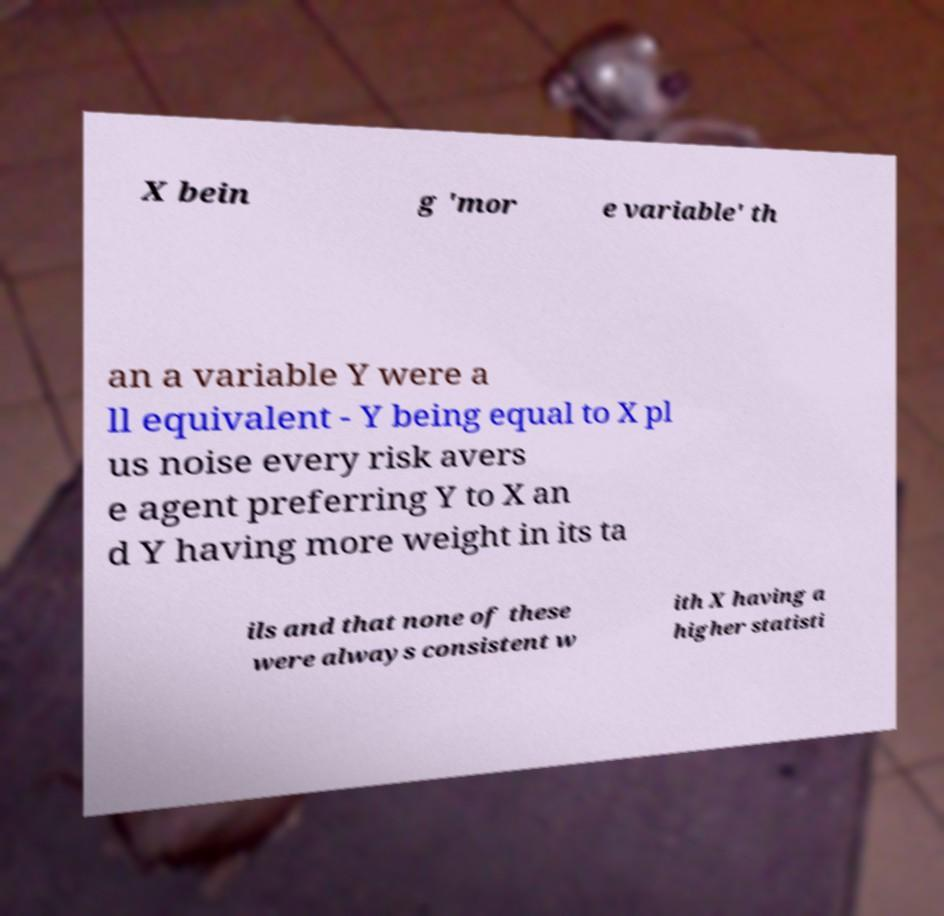Please identify and transcribe the text found in this image. X bein g 'mor e variable' th an a variable Y were a ll equivalent - Y being equal to X pl us noise every risk avers e agent preferring Y to X an d Y having more weight in its ta ils and that none of these were always consistent w ith X having a higher statisti 